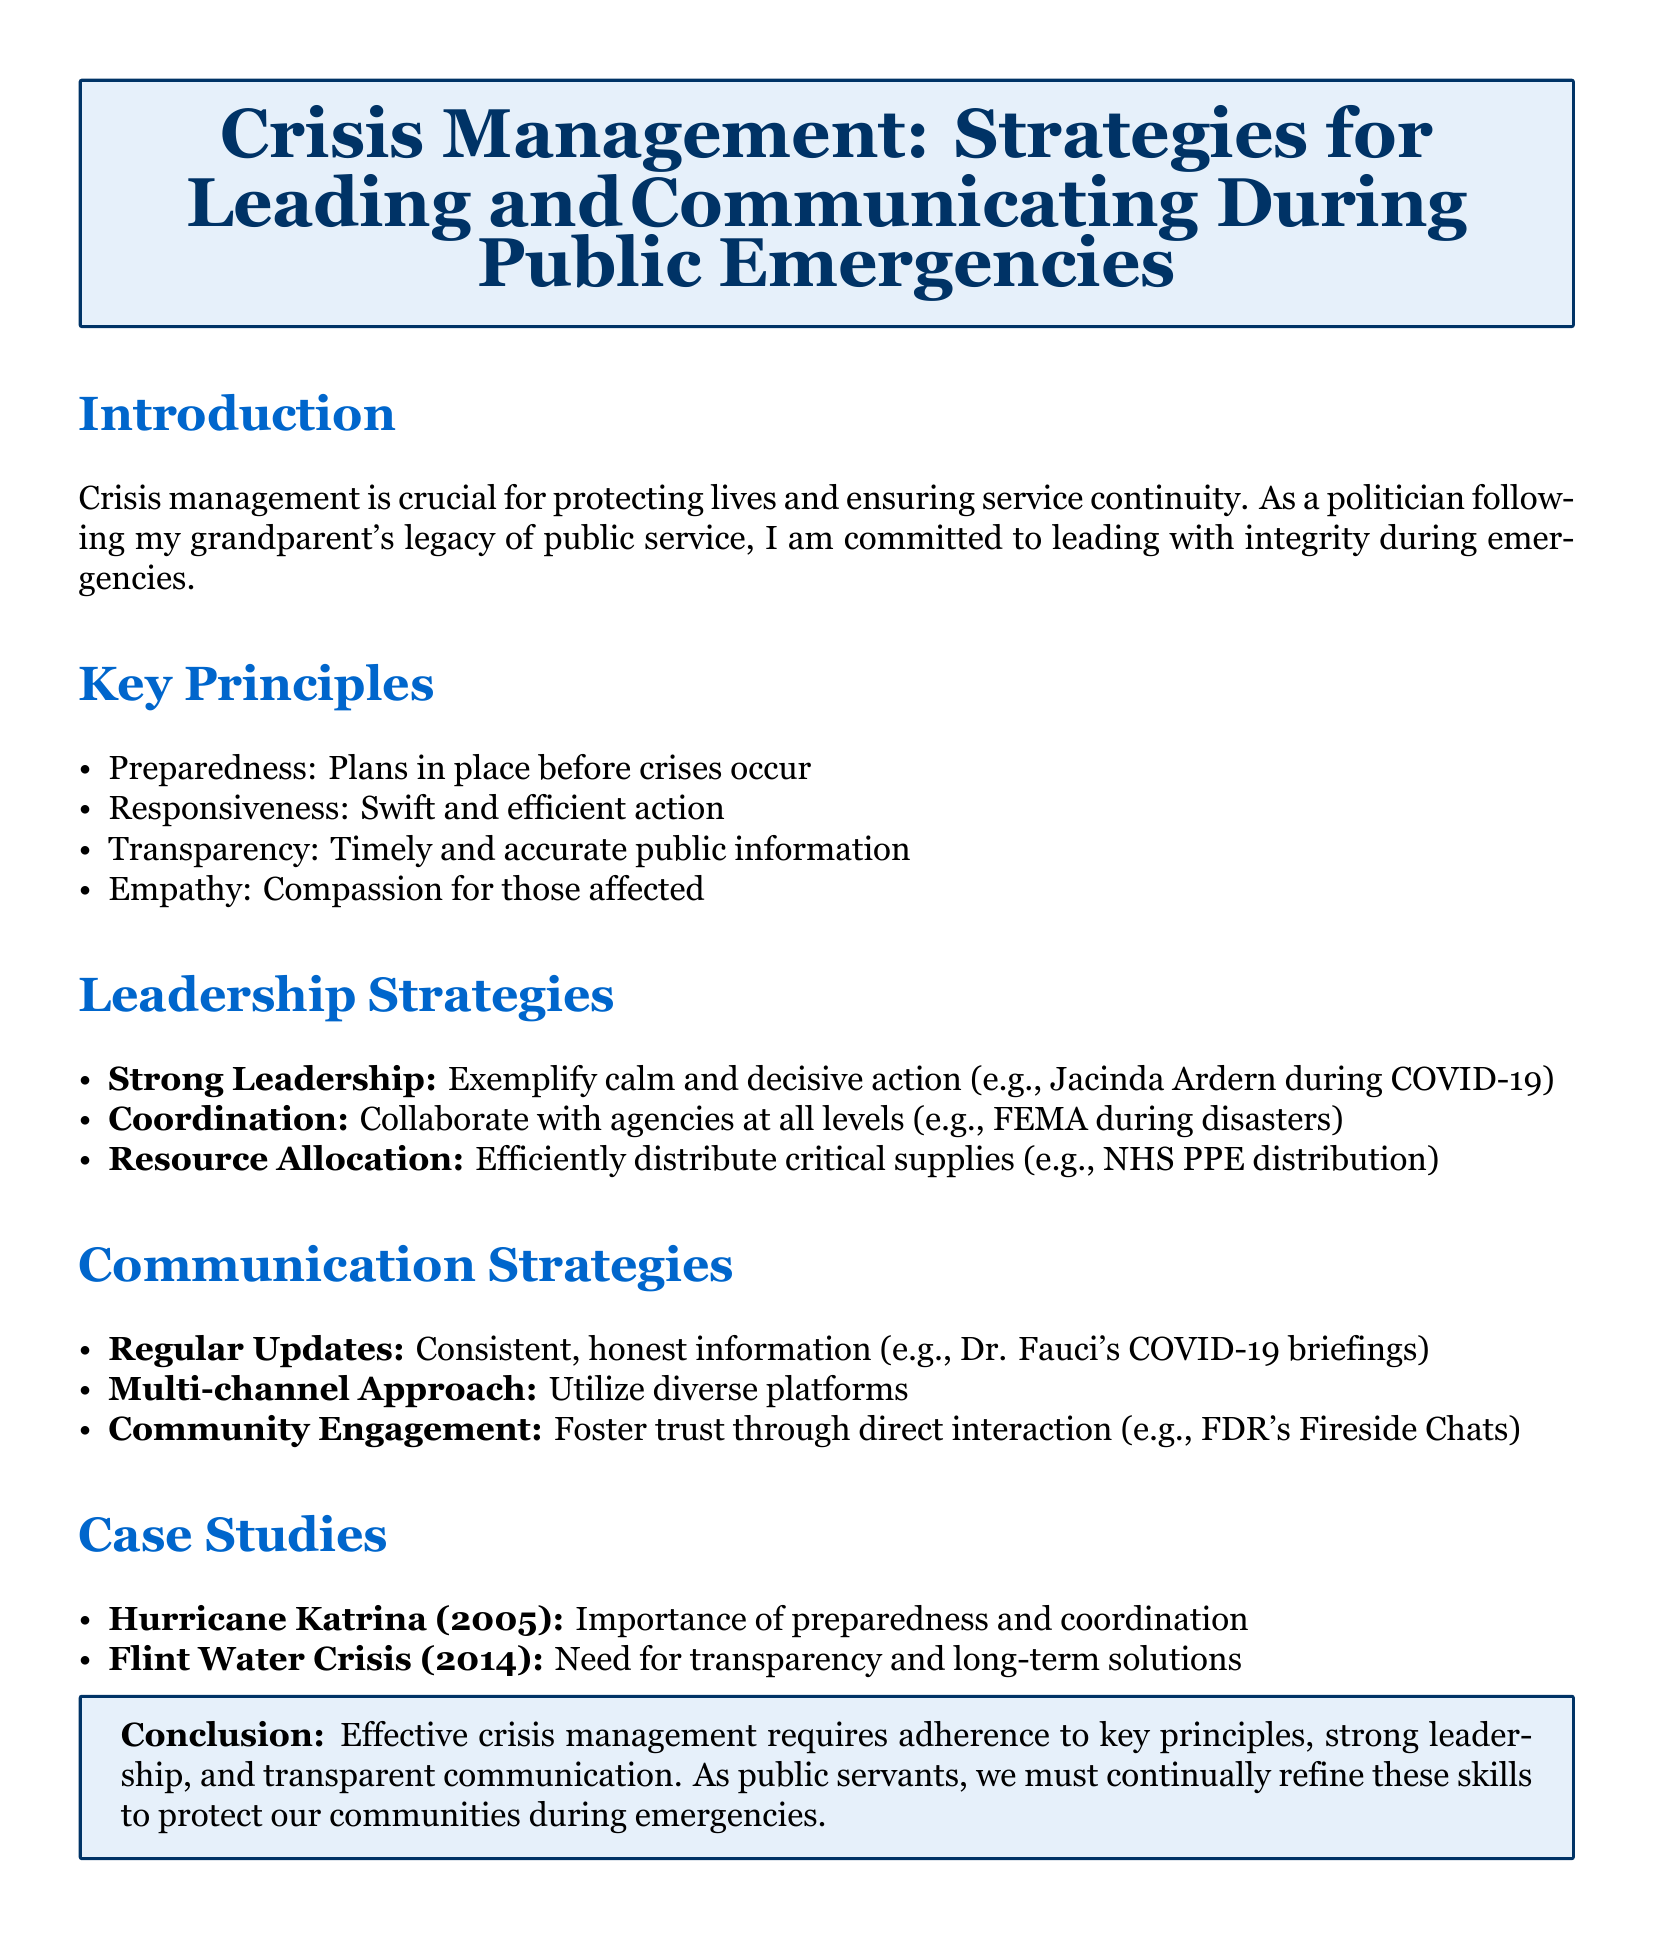What are the key principles of crisis management? The key principles are listed in the document as preparedness, responsiveness, transparency, and empathy.
Answer: Preparedness, responsiveness, transparency, empathy Who exemplified strong leadership during COVID-19? The document refers to Jacinda Ardern as an example of strong leadership during the pandemic.
Answer: Jacinda Ardern Which communication strategy involves using diverse platforms? The document mentions a multi-channel approach as a communication strategy that utilizes diverse platforms.
Answer: Multi-channel approach What year did Hurricane Katrina occur? The document specifies that Hurricane Katrina happened in 2005.
Answer: 2005 What is the main conclusion of the lesson plan? The conclusion emphasizes the importance of effective crisis management, adherence to principles, strong leadership, and communication for public servants.
Answer: Effective crisis management requires adherence to key principles, strong leadership, and transparent communication What is the focus of the case study on Flint Water Crisis? The document highlights the need for transparency and long-term solutions regarding the Flint Water Crisis.
Answer: Transparency and long-term solutions Which former U.S. president is mentioned for community engagement? The document references Franklin D. Roosevelt for his Fireside Chats as a means of community engagement.
Answer: Franklin D. Roosevelt What type of situations require responsiveness according to the lesson plan? The lesson plan states responsiveness is required in crisis situations to ensure swift and efficient action.
Answer: Crisis situations 